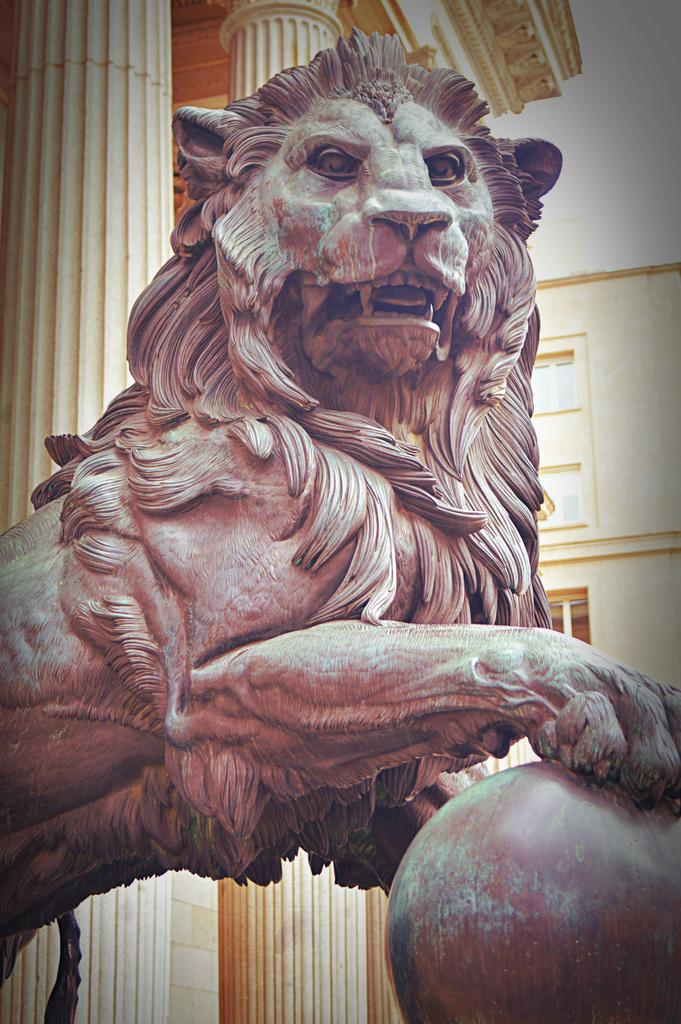What is the main subject of the image? There is a sculpture of a lion in the image. What can be seen in the background of the image? There is a building in the background of the image. Can you describe the building's features? The building has pillars and windows. What type of harmony can be heard coming from the farm in the image? There is no farm present in the image, and therefore no sounds or harmonies can be heard. 